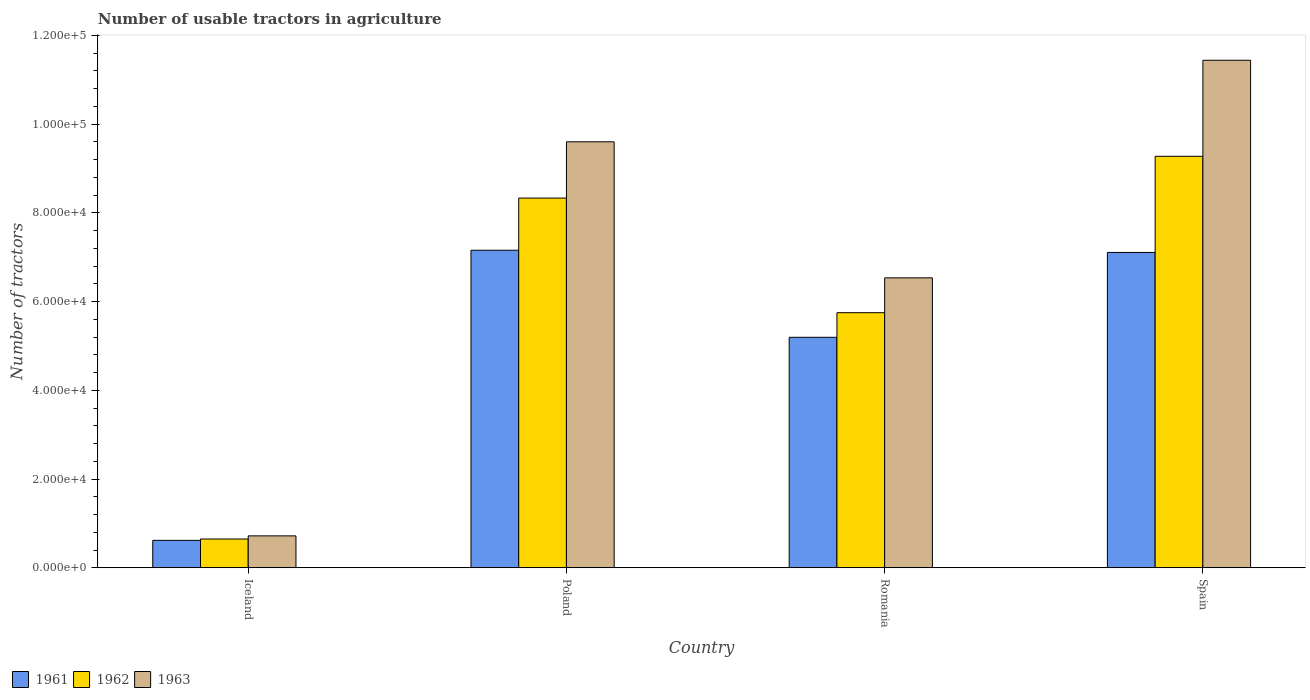How many bars are there on the 2nd tick from the right?
Offer a terse response. 3. What is the label of the 2nd group of bars from the left?
Your answer should be very brief. Poland. What is the number of usable tractors in agriculture in 1962 in Iceland?
Your answer should be compact. 6479. Across all countries, what is the maximum number of usable tractors in agriculture in 1962?
Keep it short and to the point. 9.28e+04. Across all countries, what is the minimum number of usable tractors in agriculture in 1961?
Your response must be concise. 6177. In which country was the number of usable tractors in agriculture in 1962 minimum?
Your response must be concise. Iceland. What is the total number of usable tractors in agriculture in 1963 in the graph?
Your response must be concise. 2.83e+05. What is the difference between the number of usable tractors in agriculture in 1962 in Poland and that in Romania?
Give a very brief answer. 2.58e+04. What is the difference between the number of usable tractors in agriculture in 1962 in Poland and the number of usable tractors in agriculture in 1963 in Romania?
Your answer should be compact. 1.80e+04. What is the average number of usable tractors in agriculture in 1961 per country?
Make the answer very short. 5.02e+04. What is the difference between the number of usable tractors in agriculture of/in 1962 and number of usable tractors in agriculture of/in 1961 in Romania?
Keep it short and to the point. 5548. In how many countries, is the number of usable tractors in agriculture in 1961 greater than 16000?
Offer a very short reply. 3. What is the ratio of the number of usable tractors in agriculture in 1963 in Poland to that in Romania?
Provide a succinct answer. 1.47. Is the number of usable tractors in agriculture in 1963 in Romania less than that in Spain?
Provide a succinct answer. Yes. Is the difference between the number of usable tractors in agriculture in 1962 in Iceland and Romania greater than the difference between the number of usable tractors in agriculture in 1961 in Iceland and Romania?
Make the answer very short. No. What is the difference between the highest and the second highest number of usable tractors in agriculture in 1962?
Provide a succinct answer. 3.53e+04. What is the difference between the highest and the lowest number of usable tractors in agriculture in 1961?
Provide a short and direct response. 6.54e+04. In how many countries, is the number of usable tractors in agriculture in 1961 greater than the average number of usable tractors in agriculture in 1961 taken over all countries?
Your answer should be compact. 3. What does the 3rd bar from the right in Poland represents?
Offer a very short reply. 1961. Is it the case that in every country, the sum of the number of usable tractors in agriculture in 1963 and number of usable tractors in agriculture in 1962 is greater than the number of usable tractors in agriculture in 1961?
Make the answer very short. Yes. What is the difference between two consecutive major ticks on the Y-axis?
Ensure brevity in your answer.  2.00e+04. Are the values on the major ticks of Y-axis written in scientific E-notation?
Give a very brief answer. Yes. Does the graph contain any zero values?
Your answer should be very brief. No. Does the graph contain grids?
Give a very brief answer. No. Where does the legend appear in the graph?
Keep it short and to the point. Bottom left. How many legend labels are there?
Keep it short and to the point. 3. What is the title of the graph?
Make the answer very short. Number of usable tractors in agriculture. What is the label or title of the X-axis?
Offer a terse response. Country. What is the label or title of the Y-axis?
Your response must be concise. Number of tractors. What is the Number of tractors in 1961 in Iceland?
Provide a succinct answer. 6177. What is the Number of tractors of 1962 in Iceland?
Your answer should be very brief. 6479. What is the Number of tractors of 1963 in Iceland?
Give a very brief answer. 7187. What is the Number of tractors in 1961 in Poland?
Your answer should be compact. 7.16e+04. What is the Number of tractors of 1962 in Poland?
Offer a terse response. 8.33e+04. What is the Number of tractors in 1963 in Poland?
Give a very brief answer. 9.60e+04. What is the Number of tractors in 1961 in Romania?
Make the answer very short. 5.20e+04. What is the Number of tractors of 1962 in Romania?
Offer a very short reply. 5.75e+04. What is the Number of tractors of 1963 in Romania?
Your answer should be very brief. 6.54e+04. What is the Number of tractors of 1961 in Spain?
Make the answer very short. 7.11e+04. What is the Number of tractors of 1962 in Spain?
Offer a terse response. 9.28e+04. What is the Number of tractors in 1963 in Spain?
Offer a very short reply. 1.14e+05. Across all countries, what is the maximum Number of tractors of 1961?
Offer a terse response. 7.16e+04. Across all countries, what is the maximum Number of tractors in 1962?
Give a very brief answer. 9.28e+04. Across all countries, what is the maximum Number of tractors in 1963?
Provide a succinct answer. 1.14e+05. Across all countries, what is the minimum Number of tractors of 1961?
Make the answer very short. 6177. Across all countries, what is the minimum Number of tractors in 1962?
Keep it short and to the point. 6479. Across all countries, what is the minimum Number of tractors in 1963?
Ensure brevity in your answer.  7187. What is the total Number of tractors of 1961 in the graph?
Keep it short and to the point. 2.01e+05. What is the total Number of tractors of 1962 in the graph?
Your answer should be compact. 2.40e+05. What is the total Number of tractors in 1963 in the graph?
Offer a very short reply. 2.83e+05. What is the difference between the Number of tractors in 1961 in Iceland and that in Poland?
Give a very brief answer. -6.54e+04. What is the difference between the Number of tractors of 1962 in Iceland and that in Poland?
Offer a very short reply. -7.69e+04. What is the difference between the Number of tractors of 1963 in Iceland and that in Poland?
Your answer should be compact. -8.88e+04. What is the difference between the Number of tractors of 1961 in Iceland and that in Romania?
Keep it short and to the point. -4.58e+04. What is the difference between the Number of tractors of 1962 in Iceland and that in Romania?
Keep it short and to the point. -5.10e+04. What is the difference between the Number of tractors of 1963 in Iceland and that in Romania?
Offer a terse response. -5.82e+04. What is the difference between the Number of tractors in 1961 in Iceland and that in Spain?
Provide a succinct answer. -6.49e+04. What is the difference between the Number of tractors of 1962 in Iceland and that in Spain?
Give a very brief answer. -8.63e+04. What is the difference between the Number of tractors of 1963 in Iceland and that in Spain?
Provide a succinct answer. -1.07e+05. What is the difference between the Number of tractors in 1961 in Poland and that in Romania?
Make the answer very short. 1.96e+04. What is the difference between the Number of tractors of 1962 in Poland and that in Romania?
Give a very brief answer. 2.58e+04. What is the difference between the Number of tractors of 1963 in Poland and that in Romania?
Your answer should be very brief. 3.07e+04. What is the difference between the Number of tractors of 1961 in Poland and that in Spain?
Your answer should be compact. 500. What is the difference between the Number of tractors of 1962 in Poland and that in Spain?
Offer a terse response. -9414. What is the difference between the Number of tractors of 1963 in Poland and that in Spain?
Make the answer very short. -1.84e+04. What is the difference between the Number of tractors in 1961 in Romania and that in Spain?
Provide a succinct answer. -1.91e+04. What is the difference between the Number of tractors of 1962 in Romania and that in Spain?
Your answer should be compact. -3.53e+04. What is the difference between the Number of tractors of 1963 in Romania and that in Spain?
Provide a short and direct response. -4.91e+04. What is the difference between the Number of tractors in 1961 in Iceland and the Number of tractors in 1962 in Poland?
Your response must be concise. -7.72e+04. What is the difference between the Number of tractors in 1961 in Iceland and the Number of tractors in 1963 in Poland?
Keep it short and to the point. -8.98e+04. What is the difference between the Number of tractors in 1962 in Iceland and the Number of tractors in 1963 in Poland?
Provide a succinct answer. -8.95e+04. What is the difference between the Number of tractors of 1961 in Iceland and the Number of tractors of 1962 in Romania?
Offer a terse response. -5.13e+04. What is the difference between the Number of tractors in 1961 in Iceland and the Number of tractors in 1963 in Romania?
Provide a short and direct response. -5.92e+04. What is the difference between the Number of tractors in 1962 in Iceland and the Number of tractors in 1963 in Romania?
Provide a short and direct response. -5.89e+04. What is the difference between the Number of tractors of 1961 in Iceland and the Number of tractors of 1962 in Spain?
Your answer should be very brief. -8.66e+04. What is the difference between the Number of tractors in 1961 in Iceland and the Number of tractors in 1963 in Spain?
Make the answer very short. -1.08e+05. What is the difference between the Number of tractors in 1962 in Iceland and the Number of tractors in 1963 in Spain?
Your response must be concise. -1.08e+05. What is the difference between the Number of tractors of 1961 in Poland and the Number of tractors of 1962 in Romania?
Give a very brief answer. 1.41e+04. What is the difference between the Number of tractors in 1961 in Poland and the Number of tractors in 1963 in Romania?
Ensure brevity in your answer.  6226. What is the difference between the Number of tractors in 1962 in Poland and the Number of tractors in 1963 in Romania?
Your answer should be very brief. 1.80e+04. What is the difference between the Number of tractors of 1961 in Poland and the Number of tractors of 1962 in Spain?
Offer a very short reply. -2.12e+04. What is the difference between the Number of tractors of 1961 in Poland and the Number of tractors of 1963 in Spain?
Your answer should be very brief. -4.28e+04. What is the difference between the Number of tractors of 1962 in Poland and the Number of tractors of 1963 in Spain?
Keep it short and to the point. -3.11e+04. What is the difference between the Number of tractors of 1961 in Romania and the Number of tractors of 1962 in Spain?
Make the answer very short. -4.08e+04. What is the difference between the Number of tractors of 1961 in Romania and the Number of tractors of 1963 in Spain?
Provide a succinct answer. -6.25e+04. What is the difference between the Number of tractors in 1962 in Romania and the Number of tractors in 1963 in Spain?
Your response must be concise. -5.69e+04. What is the average Number of tractors of 1961 per country?
Provide a short and direct response. 5.02e+04. What is the average Number of tractors of 1962 per country?
Your answer should be compact. 6.00e+04. What is the average Number of tractors in 1963 per country?
Your answer should be very brief. 7.07e+04. What is the difference between the Number of tractors in 1961 and Number of tractors in 1962 in Iceland?
Offer a very short reply. -302. What is the difference between the Number of tractors in 1961 and Number of tractors in 1963 in Iceland?
Offer a terse response. -1010. What is the difference between the Number of tractors in 1962 and Number of tractors in 1963 in Iceland?
Offer a very short reply. -708. What is the difference between the Number of tractors of 1961 and Number of tractors of 1962 in Poland?
Your answer should be very brief. -1.18e+04. What is the difference between the Number of tractors of 1961 and Number of tractors of 1963 in Poland?
Give a very brief answer. -2.44e+04. What is the difference between the Number of tractors in 1962 and Number of tractors in 1963 in Poland?
Your response must be concise. -1.27e+04. What is the difference between the Number of tractors in 1961 and Number of tractors in 1962 in Romania?
Your answer should be compact. -5548. What is the difference between the Number of tractors of 1961 and Number of tractors of 1963 in Romania?
Offer a very short reply. -1.34e+04. What is the difference between the Number of tractors in 1962 and Number of tractors in 1963 in Romania?
Your response must be concise. -7851. What is the difference between the Number of tractors in 1961 and Number of tractors in 1962 in Spain?
Your answer should be compact. -2.17e+04. What is the difference between the Number of tractors in 1961 and Number of tractors in 1963 in Spain?
Provide a short and direct response. -4.33e+04. What is the difference between the Number of tractors in 1962 and Number of tractors in 1963 in Spain?
Ensure brevity in your answer.  -2.17e+04. What is the ratio of the Number of tractors of 1961 in Iceland to that in Poland?
Keep it short and to the point. 0.09. What is the ratio of the Number of tractors in 1962 in Iceland to that in Poland?
Your answer should be very brief. 0.08. What is the ratio of the Number of tractors in 1963 in Iceland to that in Poland?
Your answer should be compact. 0.07. What is the ratio of the Number of tractors in 1961 in Iceland to that in Romania?
Your answer should be compact. 0.12. What is the ratio of the Number of tractors of 1962 in Iceland to that in Romania?
Keep it short and to the point. 0.11. What is the ratio of the Number of tractors in 1963 in Iceland to that in Romania?
Give a very brief answer. 0.11. What is the ratio of the Number of tractors in 1961 in Iceland to that in Spain?
Provide a succinct answer. 0.09. What is the ratio of the Number of tractors in 1962 in Iceland to that in Spain?
Keep it short and to the point. 0.07. What is the ratio of the Number of tractors of 1963 in Iceland to that in Spain?
Offer a terse response. 0.06. What is the ratio of the Number of tractors in 1961 in Poland to that in Romania?
Offer a terse response. 1.38. What is the ratio of the Number of tractors in 1962 in Poland to that in Romania?
Ensure brevity in your answer.  1.45. What is the ratio of the Number of tractors in 1963 in Poland to that in Romania?
Give a very brief answer. 1.47. What is the ratio of the Number of tractors in 1962 in Poland to that in Spain?
Provide a short and direct response. 0.9. What is the ratio of the Number of tractors in 1963 in Poland to that in Spain?
Your answer should be very brief. 0.84. What is the ratio of the Number of tractors in 1961 in Romania to that in Spain?
Make the answer very short. 0.73. What is the ratio of the Number of tractors in 1962 in Romania to that in Spain?
Offer a very short reply. 0.62. What is the ratio of the Number of tractors of 1963 in Romania to that in Spain?
Provide a short and direct response. 0.57. What is the difference between the highest and the second highest Number of tractors in 1962?
Offer a terse response. 9414. What is the difference between the highest and the second highest Number of tractors of 1963?
Ensure brevity in your answer.  1.84e+04. What is the difference between the highest and the lowest Number of tractors of 1961?
Make the answer very short. 6.54e+04. What is the difference between the highest and the lowest Number of tractors in 1962?
Offer a very short reply. 8.63e+04. What is the difference between the highest and the lowest Number of tractors in 1963?
Ensure brevity in your answer.  1.07e+05. 